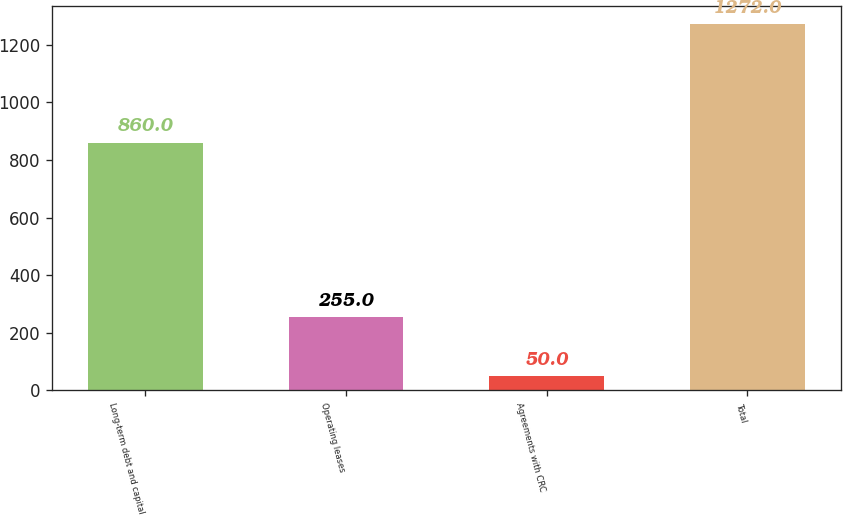Convert chart to OTSL. <chart><loc_0><loc_0><loc_500><loc_500><bar_chart><fcel>Long-term debt and capital<fcel>Operating leases<fcel>Agreements with CRC<fcel>Total<nl><fcel>860<fcel>255<fcel>50<fcel>1272<nl></chart> 